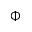Convert formula to latex. <formula><loc_0><loc_0><loc_500><loc_500>\Phi</formula> 